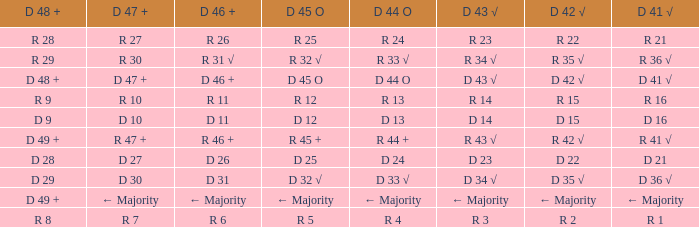What is the value of D 43 √ when the value of D 42 √ is d 42 √? D 43 √. 